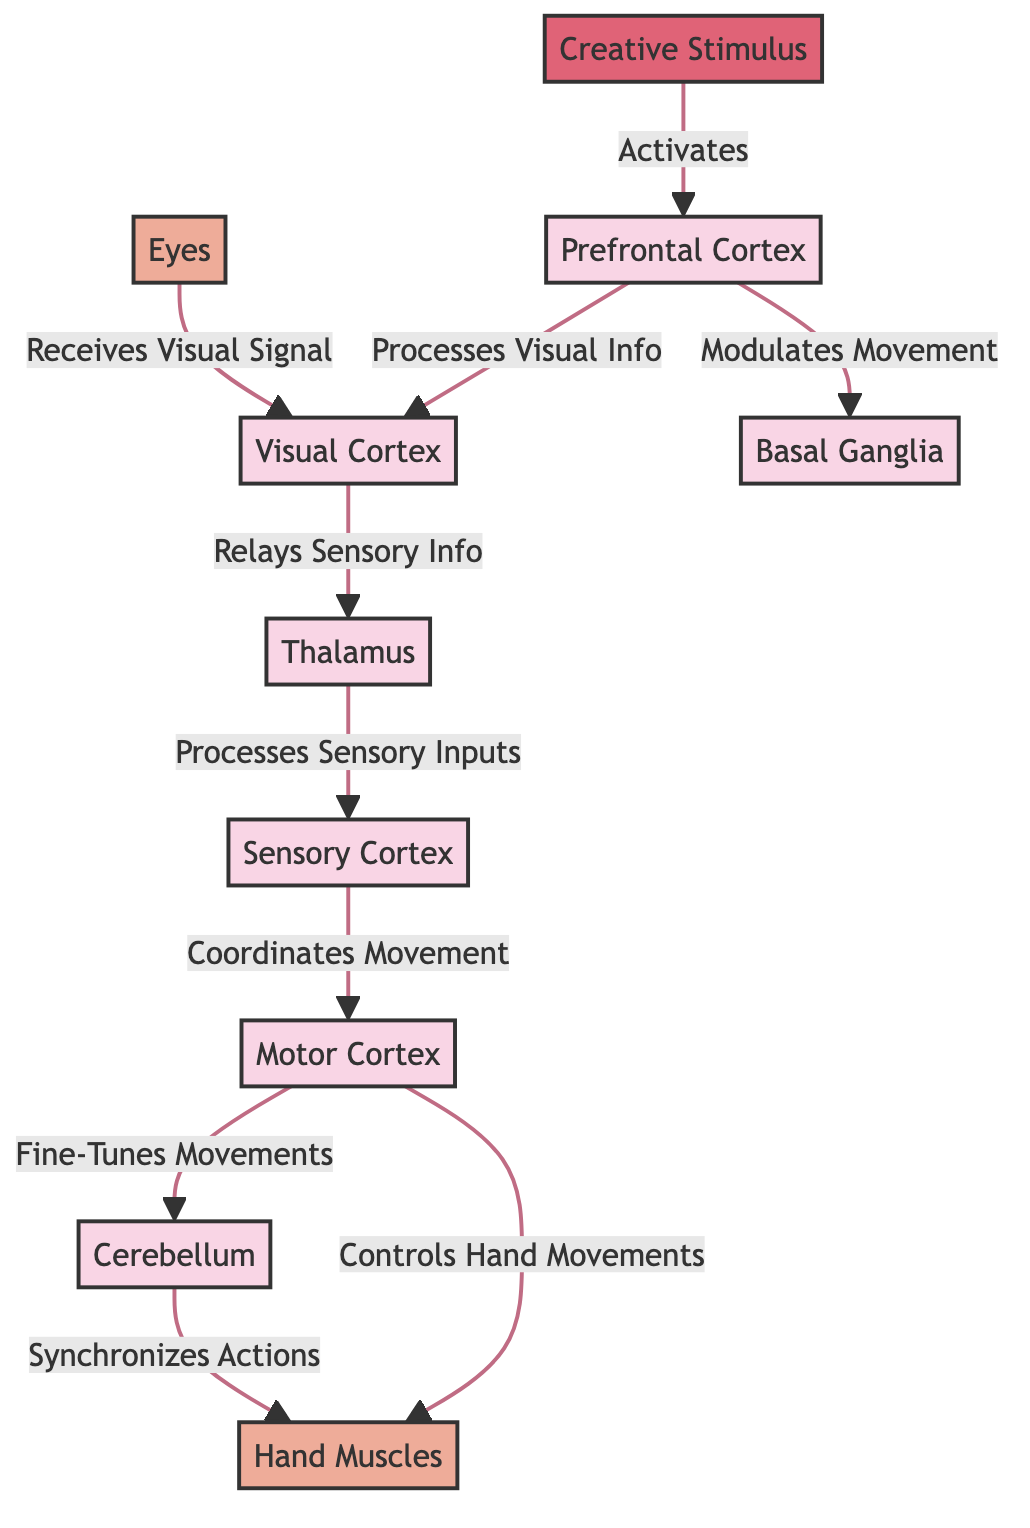What activates the Prefrontal Cortex? The diagram indicates that the Prefrontal Cortex is activated by the Creative Stimulus.
Answer: Creative Stimulus Which node processes visual information? The diagram clearly shows that the Prefrontal Cortex processes visual information and subsequently sends it to the Visual Cortex.
Answer: Prefrontal Cortex How many main brain regions are involved? By counting the distinct brain regions in the diagram, there are seven main areas: Prefrontal Cortex, Visual Cortex, Thalamus, Sensory Cortex, Motor Cortex, Basal Ganglia, and Cerebellum.
Answer: 7 What is the role of the Cerebellum? The Cerebellum fine-tunes movements and synchronizes actions with the hand muscles as indicated in the flow from the Motor Cortex to the Cerebellum then to the Hand Muscles.
Answer: Fine-tunes movements What is the sequence of activation from the Creative Stimulus to Hand Muscles? The sequence starts with the Creative Stimulus activating the Prefrontal Cortex, which processes and relays information to the Visual Cortex. The Thalamus then processes the sensory inputs sent to the Sensory Cortex, which coordinates movement. After that, the Motor Cortex controls hand movements, ultimately reaching the Hand Muscles.
Answer: Creative Stimulus → Prefrontal Cortex → Visual Cortex → Thalamus → Sensory Cortex → Motor Cortex → Hand Muscles Which node receives the visual signal? The diagram indicates that the Eyes receive the visual signal which is then sent to the Visual Cortex for processing.
Answer: Eyes What role does the Basal Ganglia play in the diagram? The Basal Ganglia modulates movement as per its connection from the Prefrontal Cortex, facilitating smoother hand-eye coordination during the creative process.
Answer: Modulates movement How does the Motor Cortex interact with the Cerebellum? The Motor Cortex sends information to the Cerebellum, which fine-tunes and synchronizes actions before they are executed by the hand muscles. This interaction is crucial for precise movements.
Answer: Fine-tunes and synchronizes actions Which component is a part of the body in the diagram? The Hand Muscles and Eyes are components depicted in the body section of the diagram, indicating their role in the physical response to creative stimuli.
Answer: Hand Muscles and Eyes 